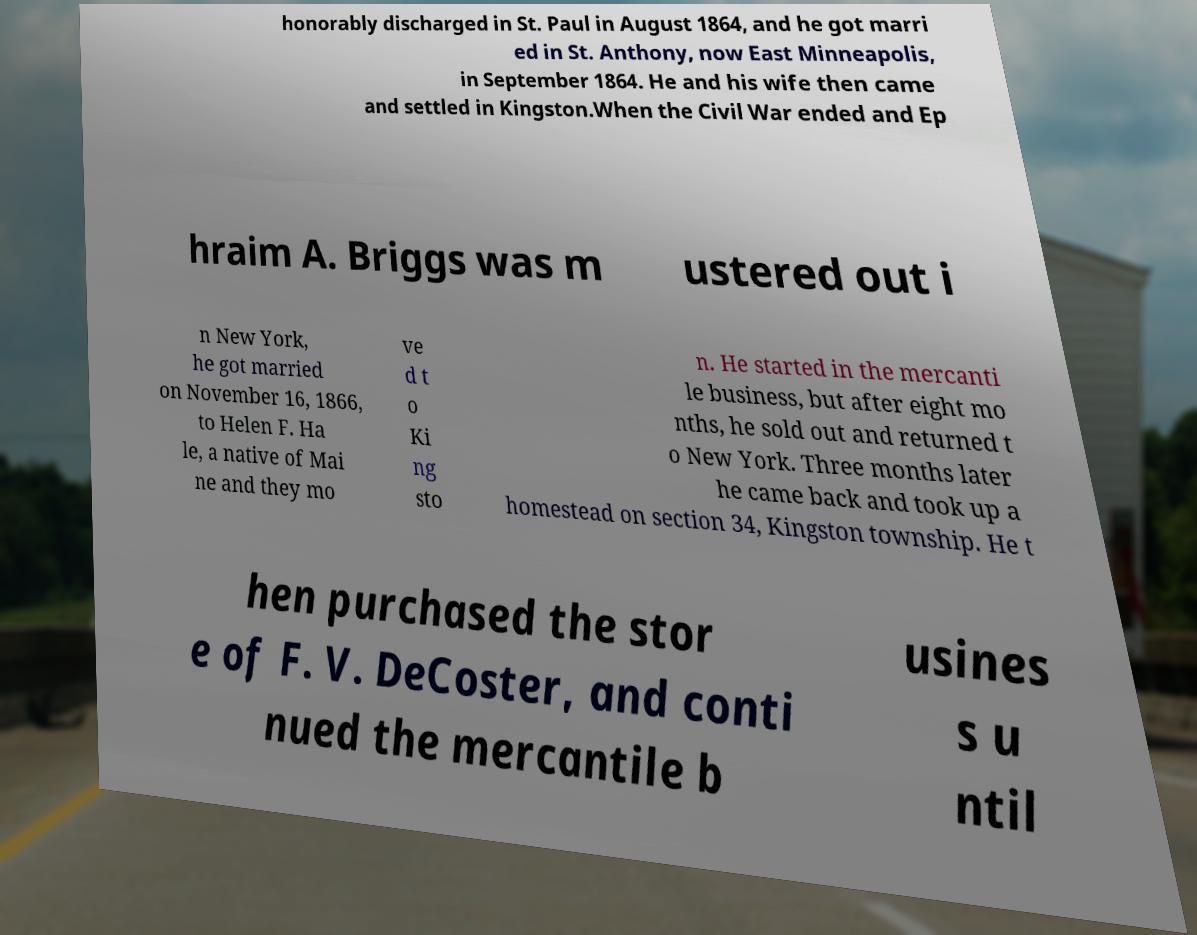Could you assist in decoding the text presented in this image and type it out clearly? honorably discharged in St. Paul in August 1864, and he got marri ed in St. Anthony, now East Minneapolis, in September 1864. He and his wife then came and settled in Kingston.When the Civil War ended and Ep hraim A. Briggs was m ustered out i n New York, he got married on November 16, 1866, to Helen F. Ha le, a native of Mai ne and they mo ve d t o Ki ng sto n. He started in the mercanti le business, but after eight mo nths, he sold out and returned t o New York. Three months later he came back and took up a homestead on section 34, Kingston township. He t hen purchased the stor e of F. V. DeCoster, and conti nued the mercantile b usines s u ntil 